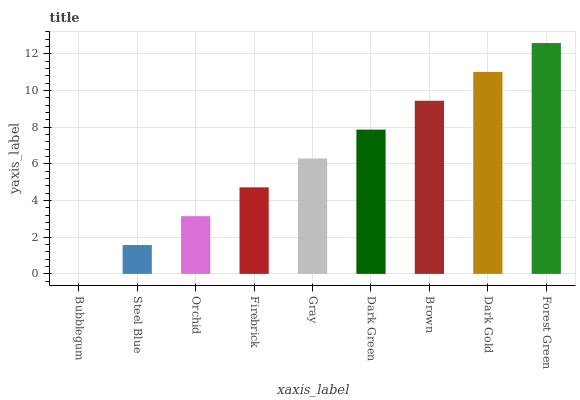Is Steel Blue the minimum?
Answer yes or no. No. Is Steel Blue the maximum?
Answer yes or no. No. Is Steel Blue greater than Bubblegum?
Answer yes or no. Yes. Is Bubblegum less than Steel Blue?
Answer yes or no. Yes. Is Bubblegum greater than Steel Blue?
Answer yes or no. No. Is Steel Blue less than Bubblegum?
Answer yes or no. No. Is Gray the high median?
Answer yes or no. Yes. Is Gray the low median?
Answer yes or no. Yes. Is Steel Blue the high median?
Answer yes or no. No. Is Bubblegum the low median?
Answer yes or no. No. 